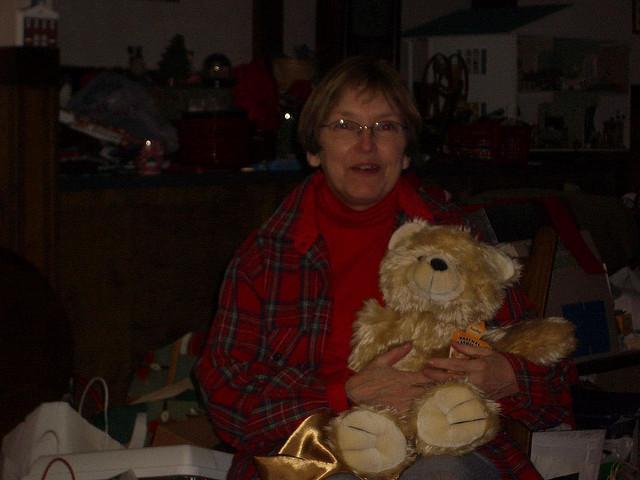Where are the eyeglasses?
Give a very brief answer. On her face. Who is wearing glasses?
Answer briefly. Woman. How many bears are in the image?
Give a very brief answer. 1. What is the bear wearing?
Keep it brief. Nothing. What is the jacket the woman is wearing?
Keep it brief. Plaid. Is one design a scarecrow?
Write a very short answer. No. How many people are there?
Quick response, please. 1. How many stuffed animals in the picture?
Be succinct. 1. What type of animal is the stuffed animal?
Give a very brief answer. Bear. Is the bear smiling?
Quick response, please. Yes. Are the teddy bears in a garden?
Quick response, please. No. How many teddy bears are in the picture?
Keep it brief. 1. Can you see teeth?
Write a very short answer. Yes. Is this a skating rink?
Answer briefly. No. How many bears are there in the picture?
Short answer required. 1. Where is the bear?
Quick response, please. In woman's arm. What is the bear sitting on?
Be succinct. Lap. How many stuffed animals are pictured?
Give a very brief answer. 1. Who is taller, the woman or the bear?
Answer briefly. Woman. Are the bears inside the house?
Answer briefly. Yes. Is there a baby on the woman's lap?
Quick response, please. No. What is the bear doing?
Keep it brief. Sitting. 